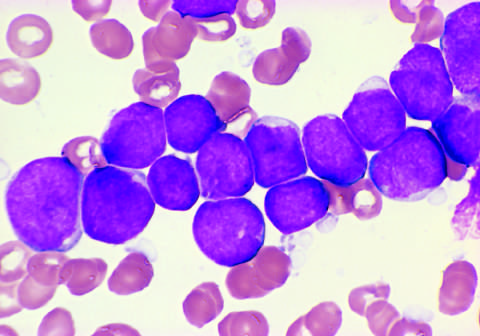s this specimen from a patient with hemolytic uremic syndrome positive for the b cell markers cd19 and cd22?
Answer the question using a single word or phrase. No 